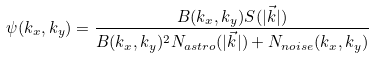<formula> <loc_0><loc_0><loc_500><loc_500>\psi ( k _ { x } , k _ { y } ) = \frac { B ( k _ { x } , k _ { y } ) S ( | \vec { k } | ) } { B ( k _ { x } , k _ { y } ) ^ { 2 } N _ { a s t r o } ( | \vec { k } | ) + N _ { n o i s e } ( k _ { x } , k _ { y } ) }</formula> 